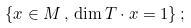<formula> <loc_0><loc_0><loc_500><loc_500>\{ x \in M \, , \, \dim T \cdot x = 1 \} \, ;</formula> 